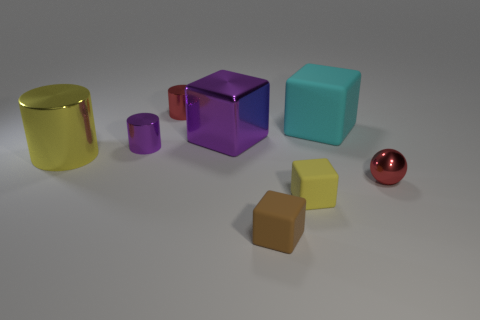Subtract all brown blocks. How many blocks are left? 3 Add 1 tiny red shiny balls. How many objects exist? 9 Subtract all blue cubes. Subtract all red cylinders. How many cubes are left? 4 Subtract all balls. How many objects are left? 7 Subtract 0 blue cylinders. How many objects are left? 8 Subtract all red balls. Subtract all small yellow matte objects. How many objects are left? 6 Add 6 small metal spheres. How many small metal spheres are left? 7 Add 7 large shiny cylinders. How many large shiny cylinders exist? 8 